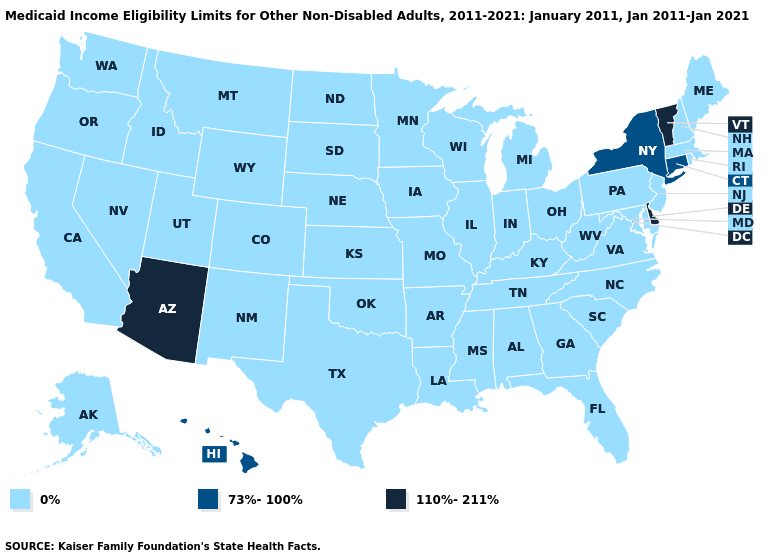Name the states that have a value in the range 110%-211%?
Be succinct. Arizona, Delaware, Vermont. Does Louisiana have the highest value in the USA?
Keep it brief. No. Does Delaware have the lowest value in the USA?
Be succinct. No. Name the states that have a value in the range 73%-100%?
Be succinct. Connecticut, Hawaii, New York. What is the value of Rhode Island?
Give a very brief answer. 0%. Does the map have missing data?
Quick response, please. No. Name the states that have a value in the range 110%-211%?
Write a very short answer. Arizona, Delaware, Vermont. What is the value of Nevada?
Concise answer only. 0%. Which states have the lowest value in the South?
Short answer required. Alabama, Arkansas, Florida, Georgia, Kentucky, Louisiana, Maryland, Mississippi, North Carolina, Oklahoma, South Carolina, Tennessee, Texas, Virginia, West Virginia. What is the highest value in the South ?
Answer briefly. 110%-211%. Which states have the lowest value in the USA?
Concise answer only. Alabama, Alaska, Arkansas, California, Colorado, Florida, Georgia, Idaho, Illinois, Indiana, Iowa, Kansas, Kentucky, Louisiana, Maine, Maryland, Massachusetts, Michigan, Minnesota, Mississippi, Missouri, Montana, Nebraska, Nevada, New Hampshire, New Jersey, New Mexico, North Carolina, North Dakota, Ohio, Oklahoma, Oregon, Pennsylvania, Rhode Island, South Carolina, South Dakota, Tennessee, Texas, Utah, Virginia, Washington, West Virginia, Wisconsin, Wyoming. Name the states that have a value in the range 110%-211%?
Write a very short answer. Arizona, Delaware, Vermont. What is the highest value in states that border New Mexico?
Quick response, please. 110%-211%. Which states hav the highest value in the Northeast?
Answer briefly. Vermont. 